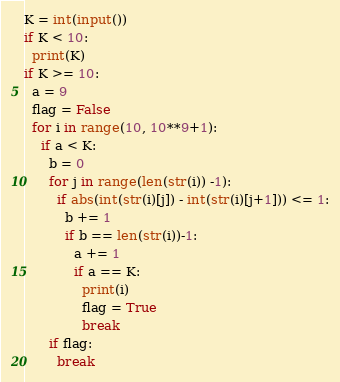Convert code to text. <code><loc_0><loc_0><loc_500><loc_500><_Python_>K = int(input())
if K < 10:
  print(K)
if K >= 10:  
  a = 9
  flag = False
  for i in range(10, 10**9+1):
    if a < K:
      b = 0
      for j in range(len(str(i)) -1):
        if abs(int(str(i)[j]) - int(str(i)[j+1])) <= 1:
          b += 1
          if b == len(str(i))-1:
            a += 1
            if a == K:
              print(i)
              flag = True
              break
      if flag:
        break</code> 